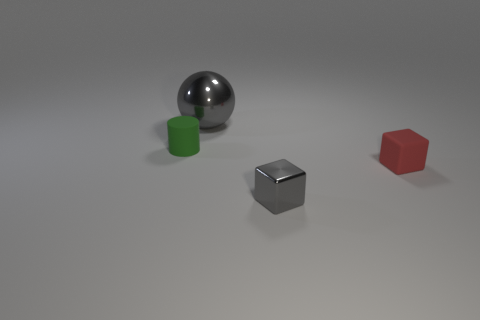What number of other objects are there of the same color as the metal sphere?
Offer a terse response. 1. What shape is the tiny rubber object that is to the left of the red block?
Make the answer very short. Cylinder. Are there fewer gray metallic things than tiny red objects?
Your response must be concise. No. Does the gray ball behind the small cylinder have the same material as the small green thing?
Offer a very short reply. No. Is there anything else that has the same size as the gray sphere?
Provide a short and direct response. No. There is a metal sphere; are there any small matte objects to the left of it?
Your answer should be compact. Yes. What is the color of the tiny rubber cylinder behind the gray thing in front of the gray object behind the red block?
Provide a succinct answer. Green. There is a gray thing that is the same size as the cylinder; what is its shape?
Keep it short and to the point. Cube. Is the number of tiny green cylinders greater than the number of tiny brown blocks?
Your answer should be very brief. Yes. Is there a red thing in front of the matte object that is to the right of the green matte object?
Provide a succinct answer. No. 